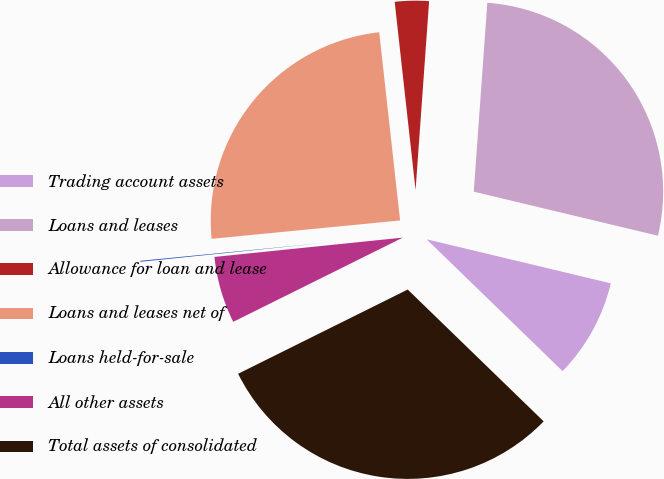Convert chart to OTSL. <chart><loc_0><loc_0><loc_500><loc_500><pie_chart><fcel>Trading account assets<fcel>Loans and leases<fcel>Allowance for loan and lease<fcel>Loans and leases net of<fcel>Loans held-for-sale<fcel>All other assets<fcel>Total assets of consolidated<nl><fcel>8.52%<fcel>27.6%<fcel>2.9%<fcel>24.79%<fcel>0.08%<fcel>5.71%<fcel>30.41%<nl></chart> 